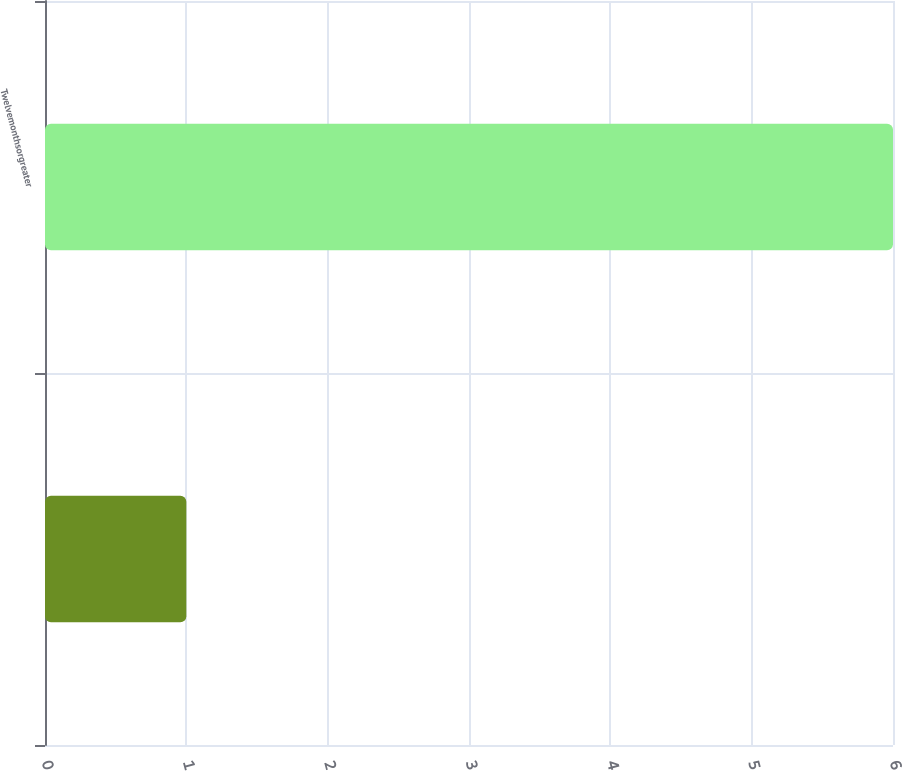Convert chart to OTSL. <chart><loc_0><loc_0><loc_500><loc_500><bar_chart><ecel><fcel>Twelvemonthsorgreater<nl><fcel>1<fcel>6<nl></chart> 